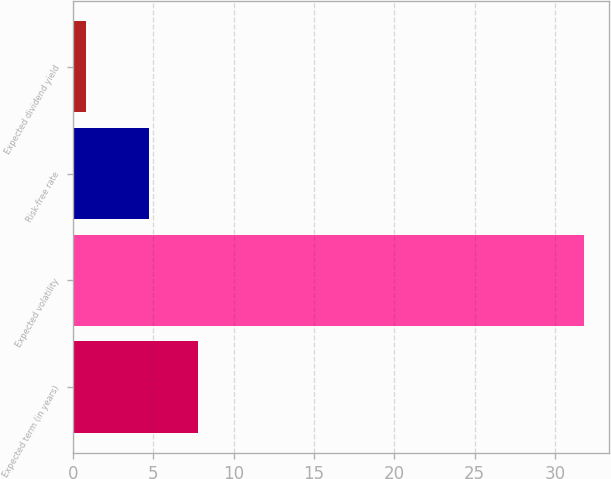Convert chart to OTSL. <chart><loc_0><loc_0><loc_500><loc_500><bar_chart><fcel>Expected term (in years)<fcel>Expected volatility<fcel>Risk-free rate<fcel>Expected dividend yield<nl><fcel>7.8<fcel>31.8<fcel>4.7<fcel>0.8<nl></chart> 